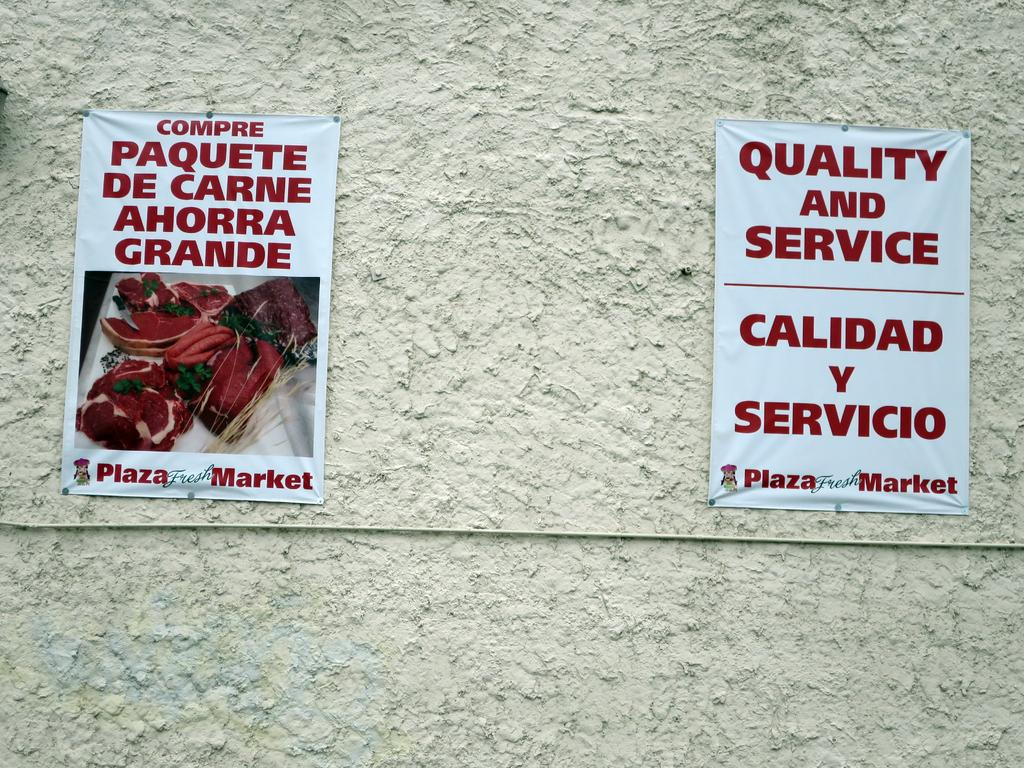What can be seen attached to the wall in the image? There are two posts attached to the wall in the image. What is featured on the posters? One poster has an image and text, while the other poster has only text. Is there a letter being delivered by a cart in the image? No, there is no letter or cart present in the image. 